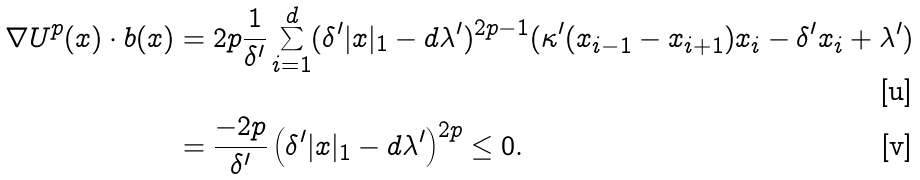Convert formula to latex. <formula><loc_0><loc_0><loc_500><loc_500>\nabla U ^ { p } ( x ) \cdot b ( x ) & = 2 p \frac { 1 } { \delta ^ { \prime } } \sum _ { i = 1 } ^ { d } ( \delta ^ { \prime } | x | _ { 1 } - d \lambda ^ { \prime } ) ^ { 2 p - 1 } ( \kappa ^ { \prime } ( x _ { i - 1 } - x _ { i + 1 } ) x _ { i } - \delta ^ { \prime } x _ { i } + \lambda ^ { \prime } ) \\ & = \frac { - 2 p } { \delta ^ { \prime } } \left ( \delta ^ { \prime } | x | _ { 1 } - d \lambda ^ { \prime } \right ) ^ { 2 p } \leq 0 .</formula> 